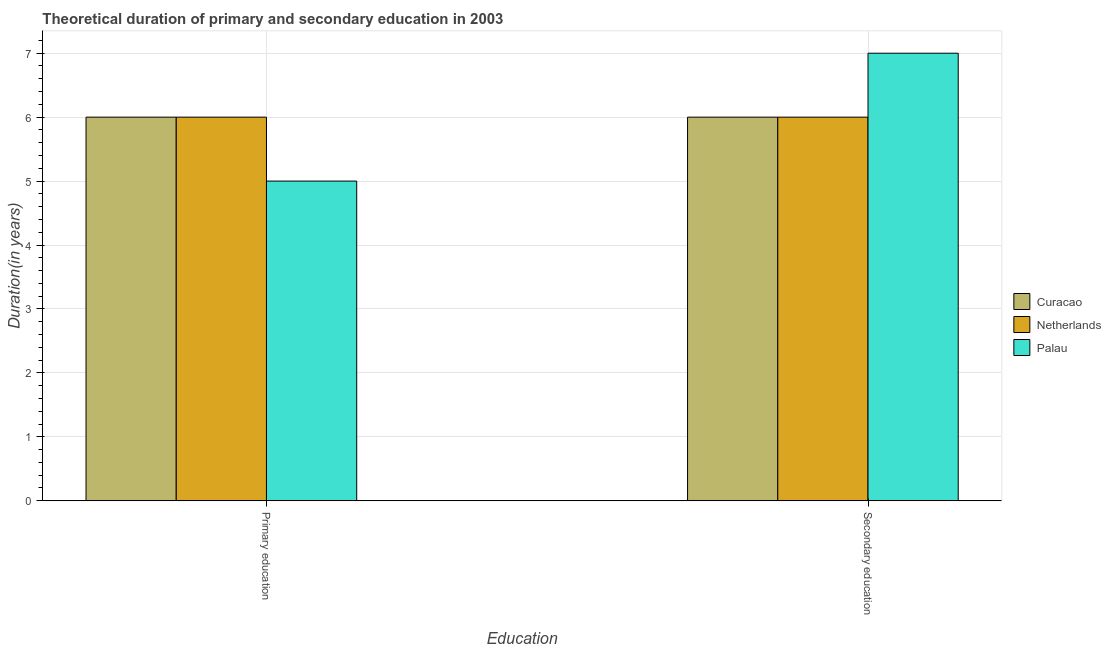How many different coloured bars are there?
Your answer should be compact. 3. How many groups of bars are there?
Your answer should be compact. 2. Are the number of bars per tick equal to the number of legend labels?
Give a very brief answer. Yes. Are the number of bars on each tick of the X-axis equal?
Offer a very short reply. Yes. How many bars are there on the 1st tick from the left?
Your answer should be very brief. 3. What is the label of the 1st group of bars from the left?
Offer a very short reply. Primary education. Across all countries, what is the maximum duration of primary education?
Offer a terse response. 6. Across all countries, what is the minimum duration of primary education?
Provide a short and direct response. 5. In which country was the duration of primary education maximum?
Your response must be concise. Curacao. In which country was the duration of primary education minimum?
Your answer should be compact. Palau. What is the total duration of secondary education in the graph?
Your response must be concise. 19. What is the difference between the duration of primary education in Netherlands and the duration of secondary education in Palau?
Ensure brevity in your answer.  -1. What is the average duration of primary education per country?
Your answer should be very brief. 5.67. What is the difference between the duration of secondary education and duration of primary education in Palau?
Offer a very short reply. 2. What is the ratio of the duration of secondary education in Palau to that in Curacao?
Your answer should be very brief. 1.17. In how many countries, is the duration of primary education greater than the average duration of primary education taken over all countries?
Your response must be concise. 2. What does the 1st bar from the left in Primary education represents?
Keep it short and to the point. Curacao. Are all the bars in the graph horizontal?
Offer a terse response. No. How many countries are there in the graph?
Your response must be concise. 3. What is the difference between two consecutive major ticks on the Y-axis?
Ensure brevity in your answer.  1. Does the graph contain any zero values?
Keep it short and to the point. No. Where does the legend appear in the graph?
Your response must be concise. Center right. How many legend labels are there?
Offer a terse response. 3. What is the title of the graph?
Give a very brief answer. Theoretical duration of primary and secondary education in 2003. What is the label or title of the X-axis?
Make the answer very short. Education. What is the label or title of the Y-axis?
Keep it short and to the point. Duration(in years). What is the Duration(in years) of Curacao in Primary education?
Offer a terse response. 6. What is the Duration(in years) in Palau in Primary education?
Your response must be concise. 5. Across all Education, what is the minimum Duration(in years) of Curacao?
Provide a succinct answer. 6. Across all Education, what is the minimum Duration(in years) in Netherlands?
Keep it short and to the point. 6. What is the total Duration(in years) of Curacao in the graph?
Your answer should be compact. 12. What is the total Duration(in years) of Netherlands in the graph?
Ensure brevity in your answer.  12. What is the difference between the Duration(in years) in Netherlands in Primary education and that in Secondary education?
Make the answer very short. 0. What is the difference between the Duration(in years) of Curacao in Primary education and the Duration(in years) of Netherlands in Secondary education?
Ensure brevity in your answer.  0. What is the difference between the Duration(in years) in Netherlands in Primary education and the Duration(in years) in Palau in Secondary education?
Offer a very short reply. -1. What is the average Duration(in years) of Netherlands per Education?
Provide a short and direct response. 6. What is the average Duration(in years) in Palau per Education?
Offer a terse response. 6. What is the difference between the Duration(in years) in Curacao and Duration(in years) in Netherlands in Primary education?
Offer a very short reply. 0. What is the difference between the Duration(in years) in Curacao and Duration(in years) in Netherlands in Secondary education?
Give a very brief answer. 0. What is the difference between the Duration(in years) in Netherlands and Duration(in years) in Palau in Secondary education?
Make the answer very short. -1. What is the ratio of the Duration(in years) in Netherlands in Primary education to that in Secondary education?
Your answer should be very brief. 1. What is the ratio of the Duration(in years) in Palau in Primary education to that in Secondary education?
Your response must be concise. 0.71. What is the difference between the highest and the second highest Duration(in years) in Curacao?
Offer a very short reply. 0. What is the difference between the highest and the second highest Duration(in years) of Palau?
Offer a very short reply. 2. What is the difference between the highest and the lowest Duration(in years) in Netherlands?
Make the answer very short. 0. 